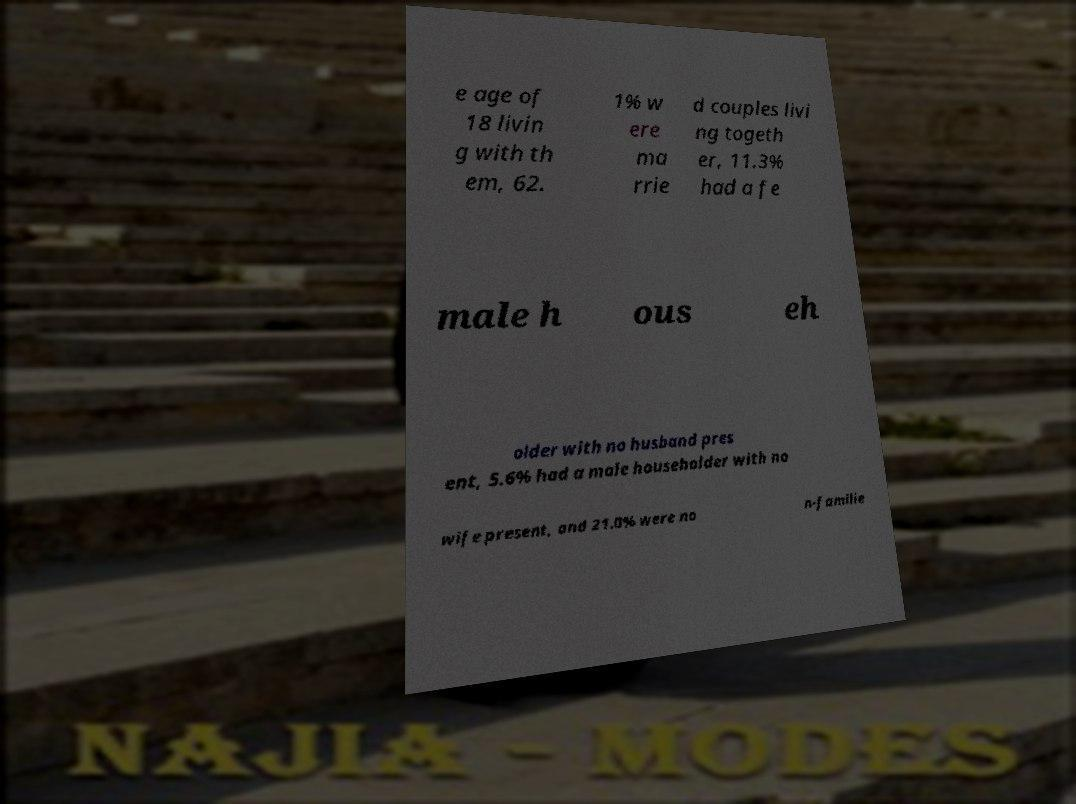Can you read and provide the text displayed in the image?This photo seems to have some interesting text. Can you extract and type it out for me? e age of 18 livin g with th em, 62. 1% w ere ma rrie d couples livi ng togeth er, 11.3% had a fe male h ous eh older with no husband pres ent, 5.6% had a male householder with no wife present, and 21.0% were no n-familie 